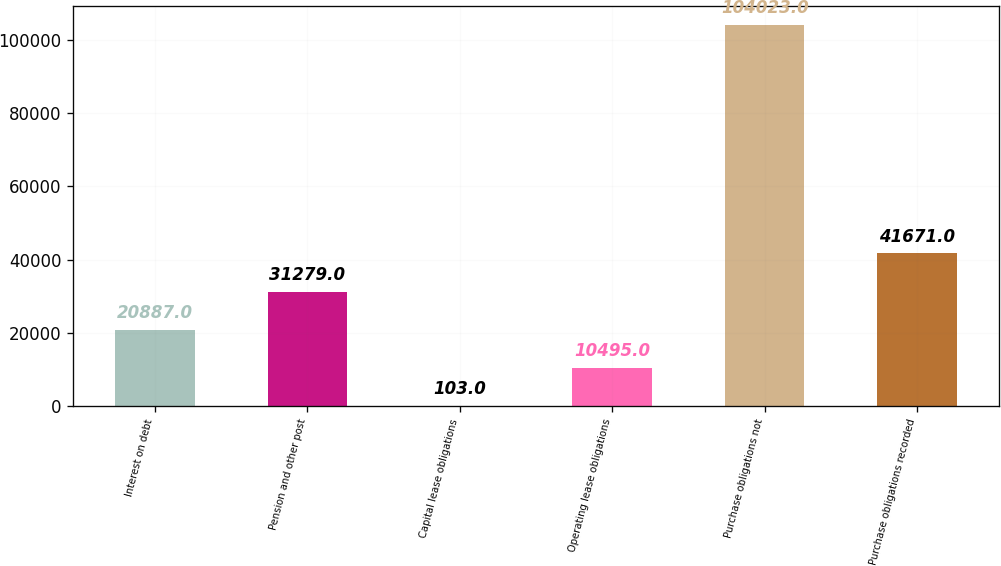Convert chart to OTSL. <chart><loc_0><loc_0><loc_500><loc_500><bar_chart><fcel>Interest on debt<fcel>Pension and other post<fcel>Capital lease obligations<fcel>Operating lease obligations<fcel>Purchase obligations not<fcel>Purchase obligations recorded<nl><fcel>20887<fcel>31279<fcel>103<fcel>10495<fcel>104023<fcel>41671<nl></chart> 